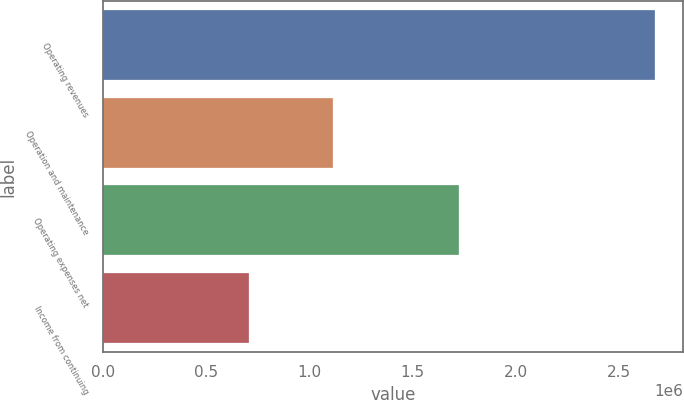Convert chart. <chart><loc_0><loc_0><loc_500><loc_500><bar_chart><fcel>Operating revenues<fcel>Operation and maintenance<fcel>Operating expenses net<fcel>Income from continuing<nl><fcel>2.67433e+06<fcel>1.11151e+06<fcel>1.72565e+06<fcel>707449<nl></chart> 